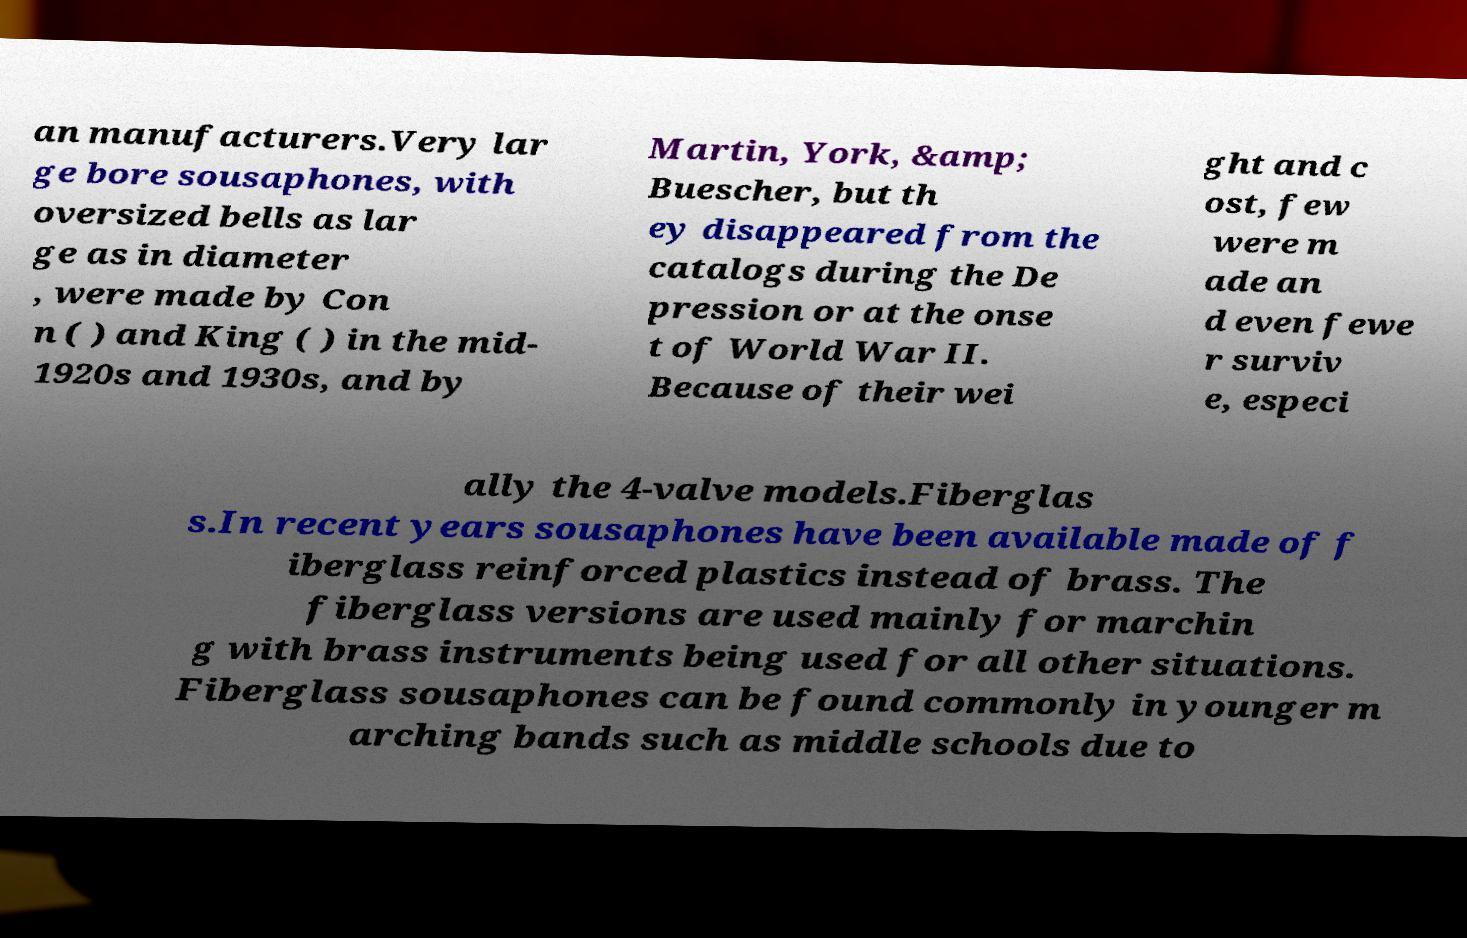Can you read and provide the text displayed in the image?This photo seems to have some interesting text. Can you extract and type it out for me? an manufacturers.Very lar ge bore sousaphones, with oversized bells as lar ge as in diameter , were made by Con n ( ) and King ( ) in the mid- 1920s and 1930s, and by Martin, York, &amp; Buescher, but th ey disappeared from the catalogs during the De pression or at the onse t of World War II. Because of their wei ght and c ost, few were m ade an d even fewe r surviv e, especi ally the 4-valve models.Fiberglas s.In recent years sousaphones have been available made of f iberglass reinforced plastics instead of brass. The fiberglass versions are used mainly for marchin g with brass instruments being used for all other situations. Fiberglass sousaphones can be found commonly in younger m arching bands such as middle schools due to 